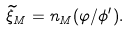Convert formula to latex. <formula><loc_0><loc_0><loc_500><loc_500>\widetilde { \xi } _ { M } = n _ { M } ( \varphi / \phi ^ { \prime } ) .</formula> 